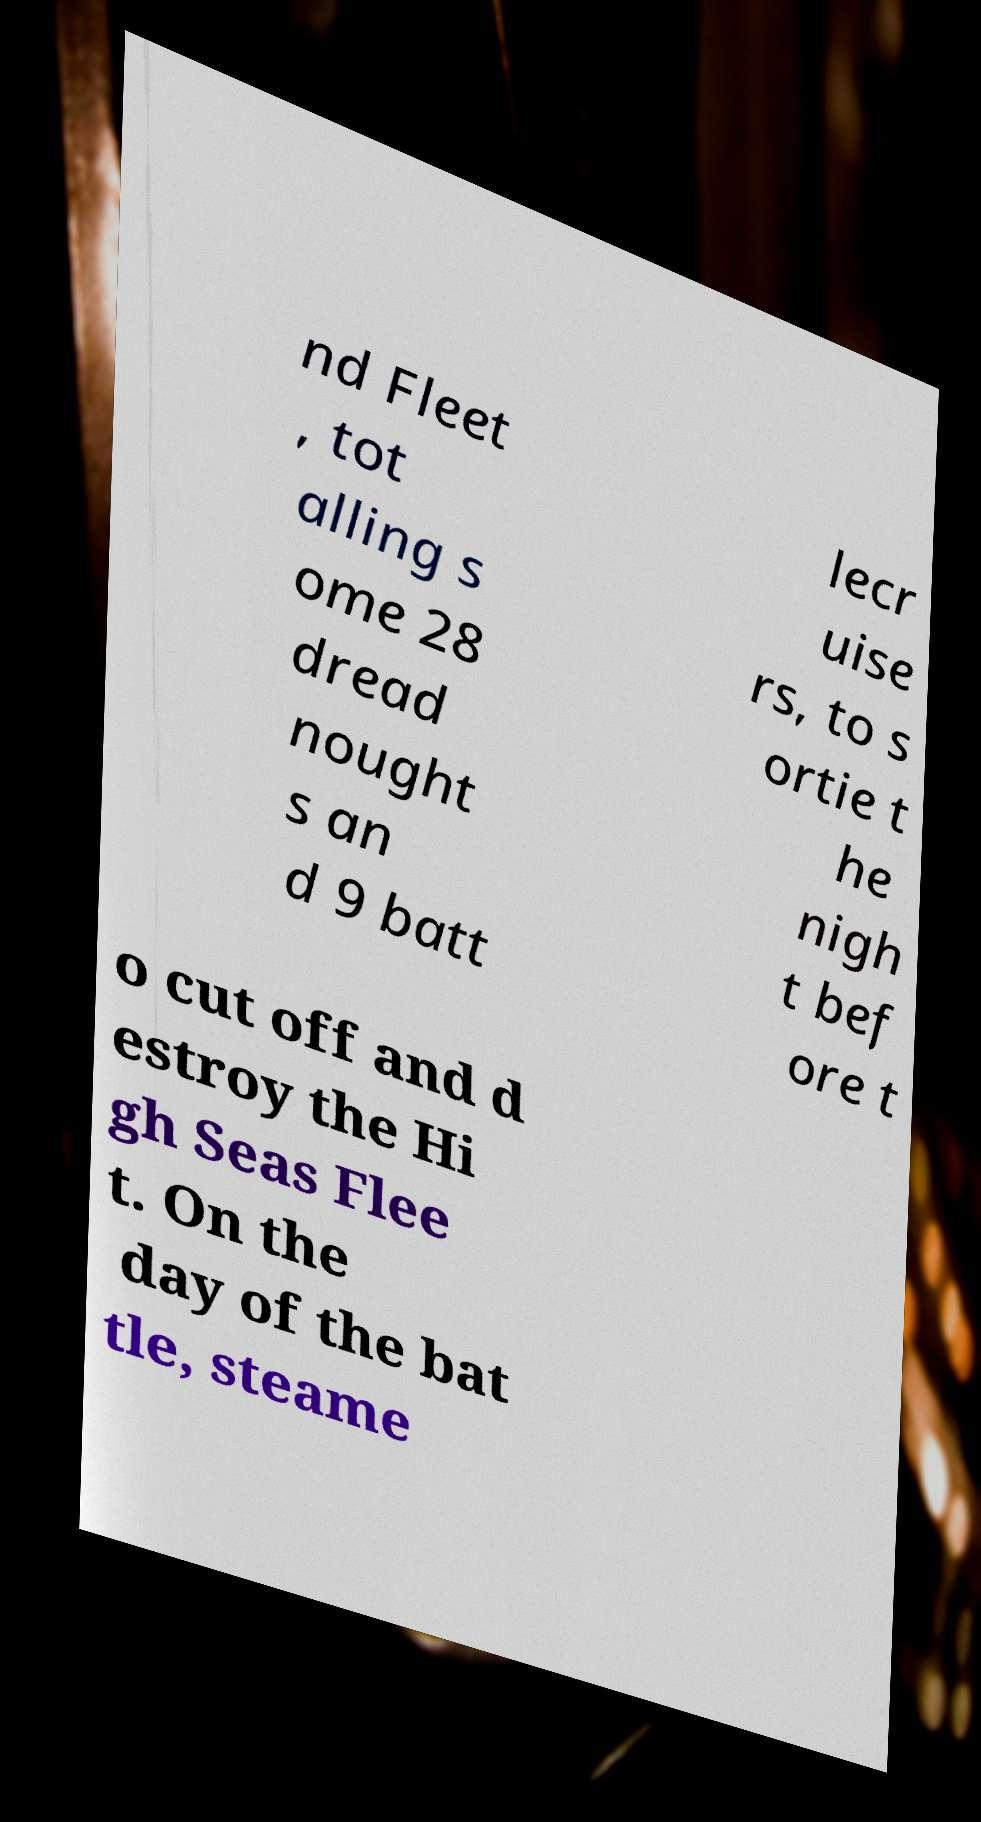Could you extract and type out the text from this image? nd Fleet , tot alling s ome 28 dread nought s an d 9 batt lecr uise rs, to s ortie t he nigh t bef ore t o cut off and d estroy the Hi gh Seas Flee t. On the day of the bat tle, steame 